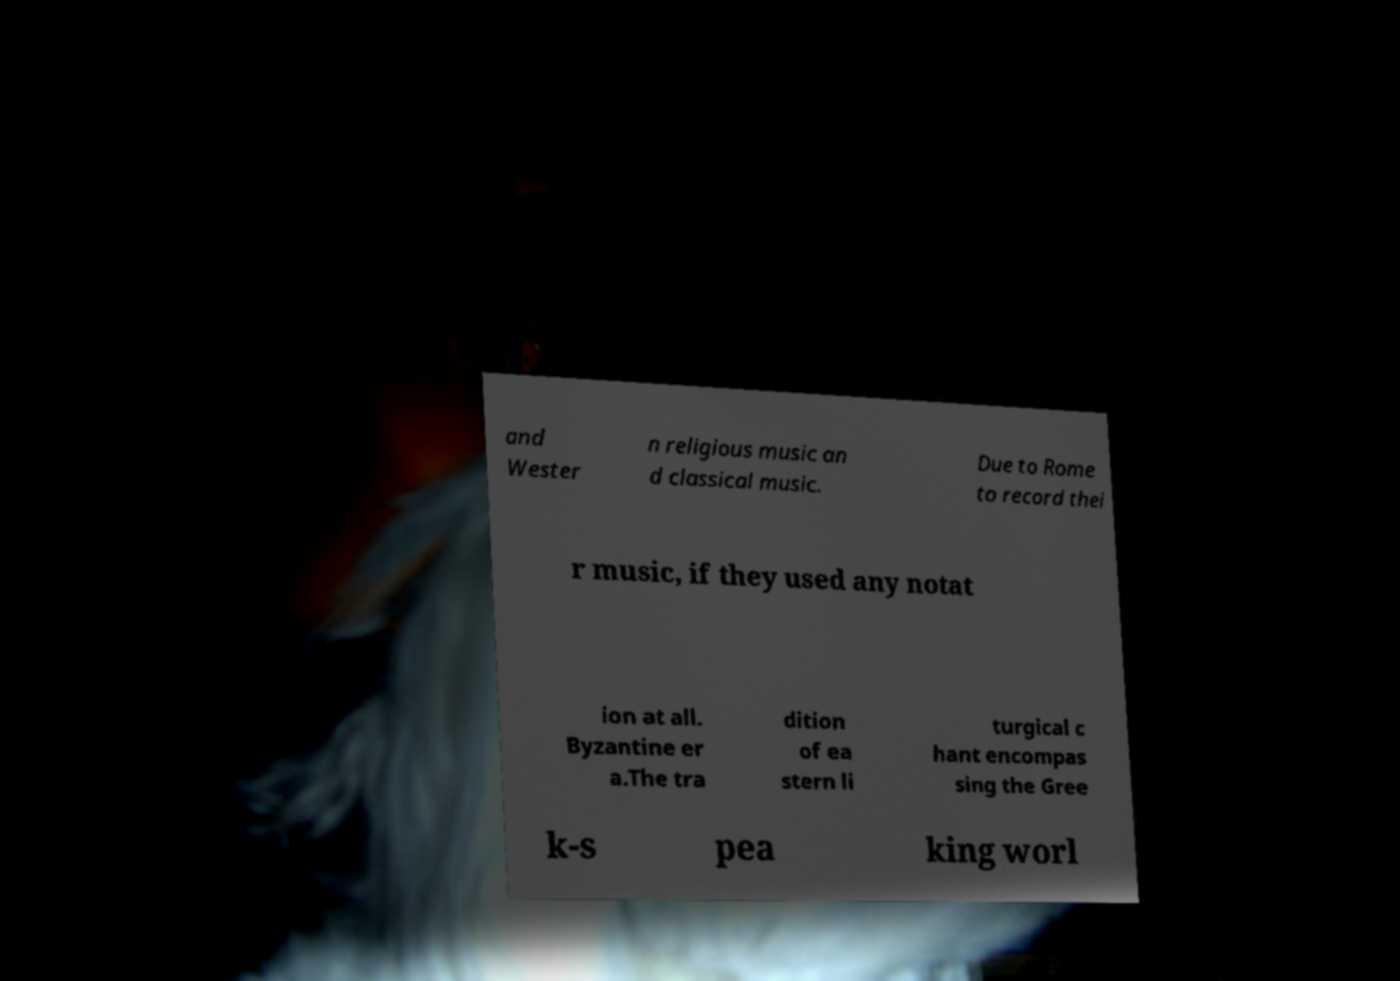Can you accurately transcribe the text from the provided image for me? and Wester n religious music an d classical music. Due to Rome to record thei r music, if they used any notat ion at all. Byzantine er a.The tra dition of ea stern li turgical c hant encompas sing the Gree k-s pea king worl 